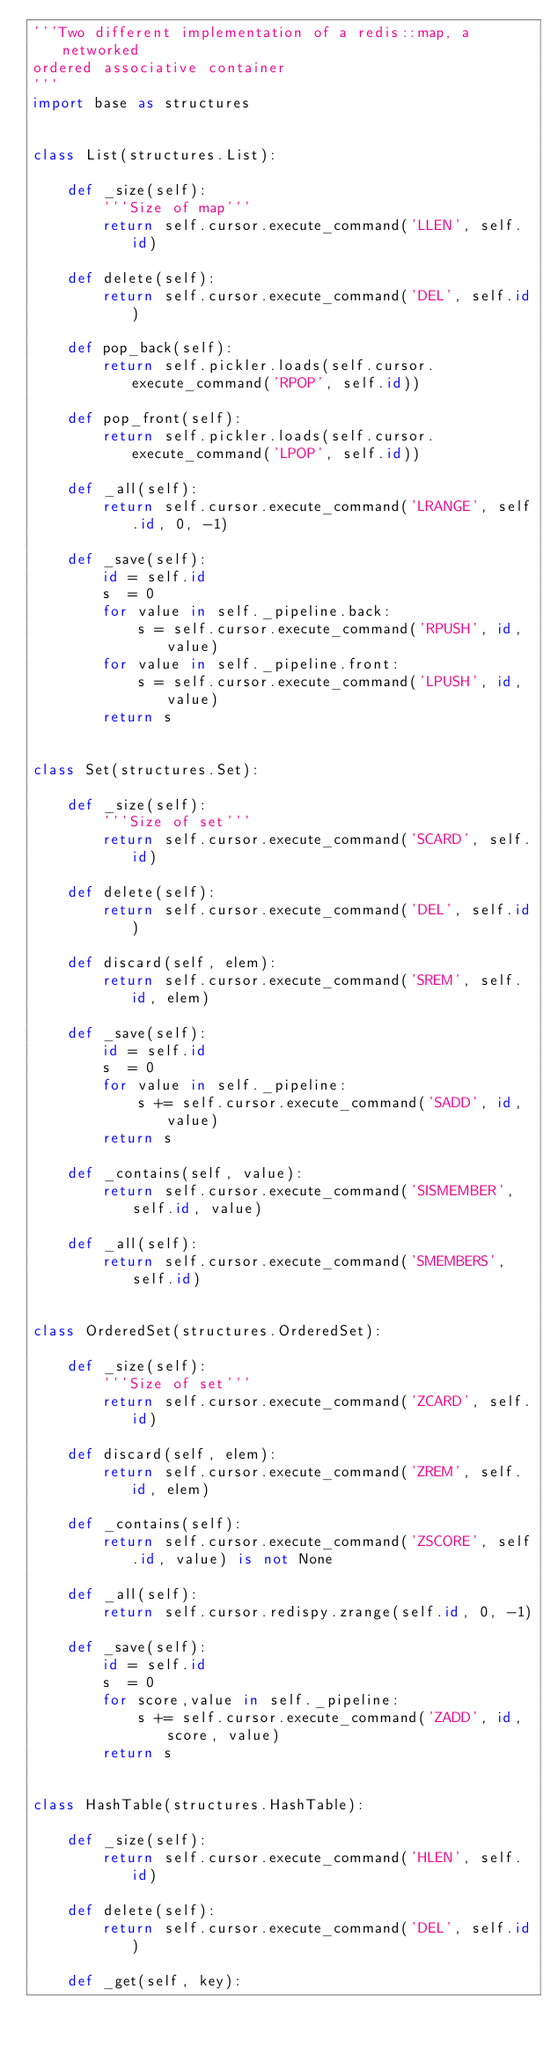Convert code to text. <code><loc_0><loc_0><loc_500><loc_500><_Python_>'''Two different implementation of a redis::map, a networked
ordered associative container
'''
import base as structures


class List(structures.List):
    
    def _size(self):
        '''Size of map'''
        return self.cursor.execute_command('LLEN', self.id)
    
    def delete(self):
        return self.cursor.execute_command('DEL', self.id)
    
    def pop_back(self):
        return self.pickler.loads(self.cursor.execute_command('RPOP', self.id))
    
    def pop_front(self):
        return self.pickler.loads(self.cursor.execute_command('LPOP', self.id))
    
    def _all(self):
        return self.cursor.execute_command('LRANGE', self.id, 0, -1)
    
    def _save(self):
        id = self.id
        s  = 0
        for value in self._pipeline.back:
            s = self.cursor.execute_command('RPUSH', id, value)
        for value in self._pipeline.front:
            s = self.cursor.execute_command('LPUSH', id, value)
        return s
        

class Set(structures.Set):
    
    def _size(self):
        '''Size of set'''
        return self.cursor.execute_command('SCARD', self.id)
    
    def delete(self):
        return self.cursor.execute_command('DEL', self.id)
    
    def discard(self, elem):
        return self.cursor.execute_command('SREM', self.id, elem)
    
    def _save(self):
        id = self.id
        s  = 0
        for value in self._pipeline:
            s += self.cursor.execute_command('SADD', id, value)
        return s
    
    def _contains(self, value):
        return self.cursor.execute_command('SISMEMBER', self.id, value)
    
    def _all(self):
        return self.cursor.execute_command('SMEMBERS', self.id)
    
    
class OrderedSet(structures.OrderedSet):
    
    def _size(self):
        '''Size of set'''
        return self.cursor.execute_command('ZCARD', self.id)
    
    def discard(self, elem):
        return self.cursor.execute_command('ZREM', self.id, elem)
    
    def _contains(self):
        return self.cursor.execute_command('ZSCORE', self.id, value) is not None
    
    def _all(self):
        return self.cursor.redispy.zrange(self.id, 0, -1)
    
    def _save(self):
        id = self.id
        s  = 0
        for score,value in self._pipeline:
            s += self.cursor.execute_command('ZADD', id, score, value)
        return s


class HashTable(structures.HashTable):
    
    def _size(self):
        return self.cursor.execute_command('HLEN', self.id)
    
    def delete(self):
        return self.cursor.execute_command('DEL', self.id)
    
    def _get(self, key):</code> 